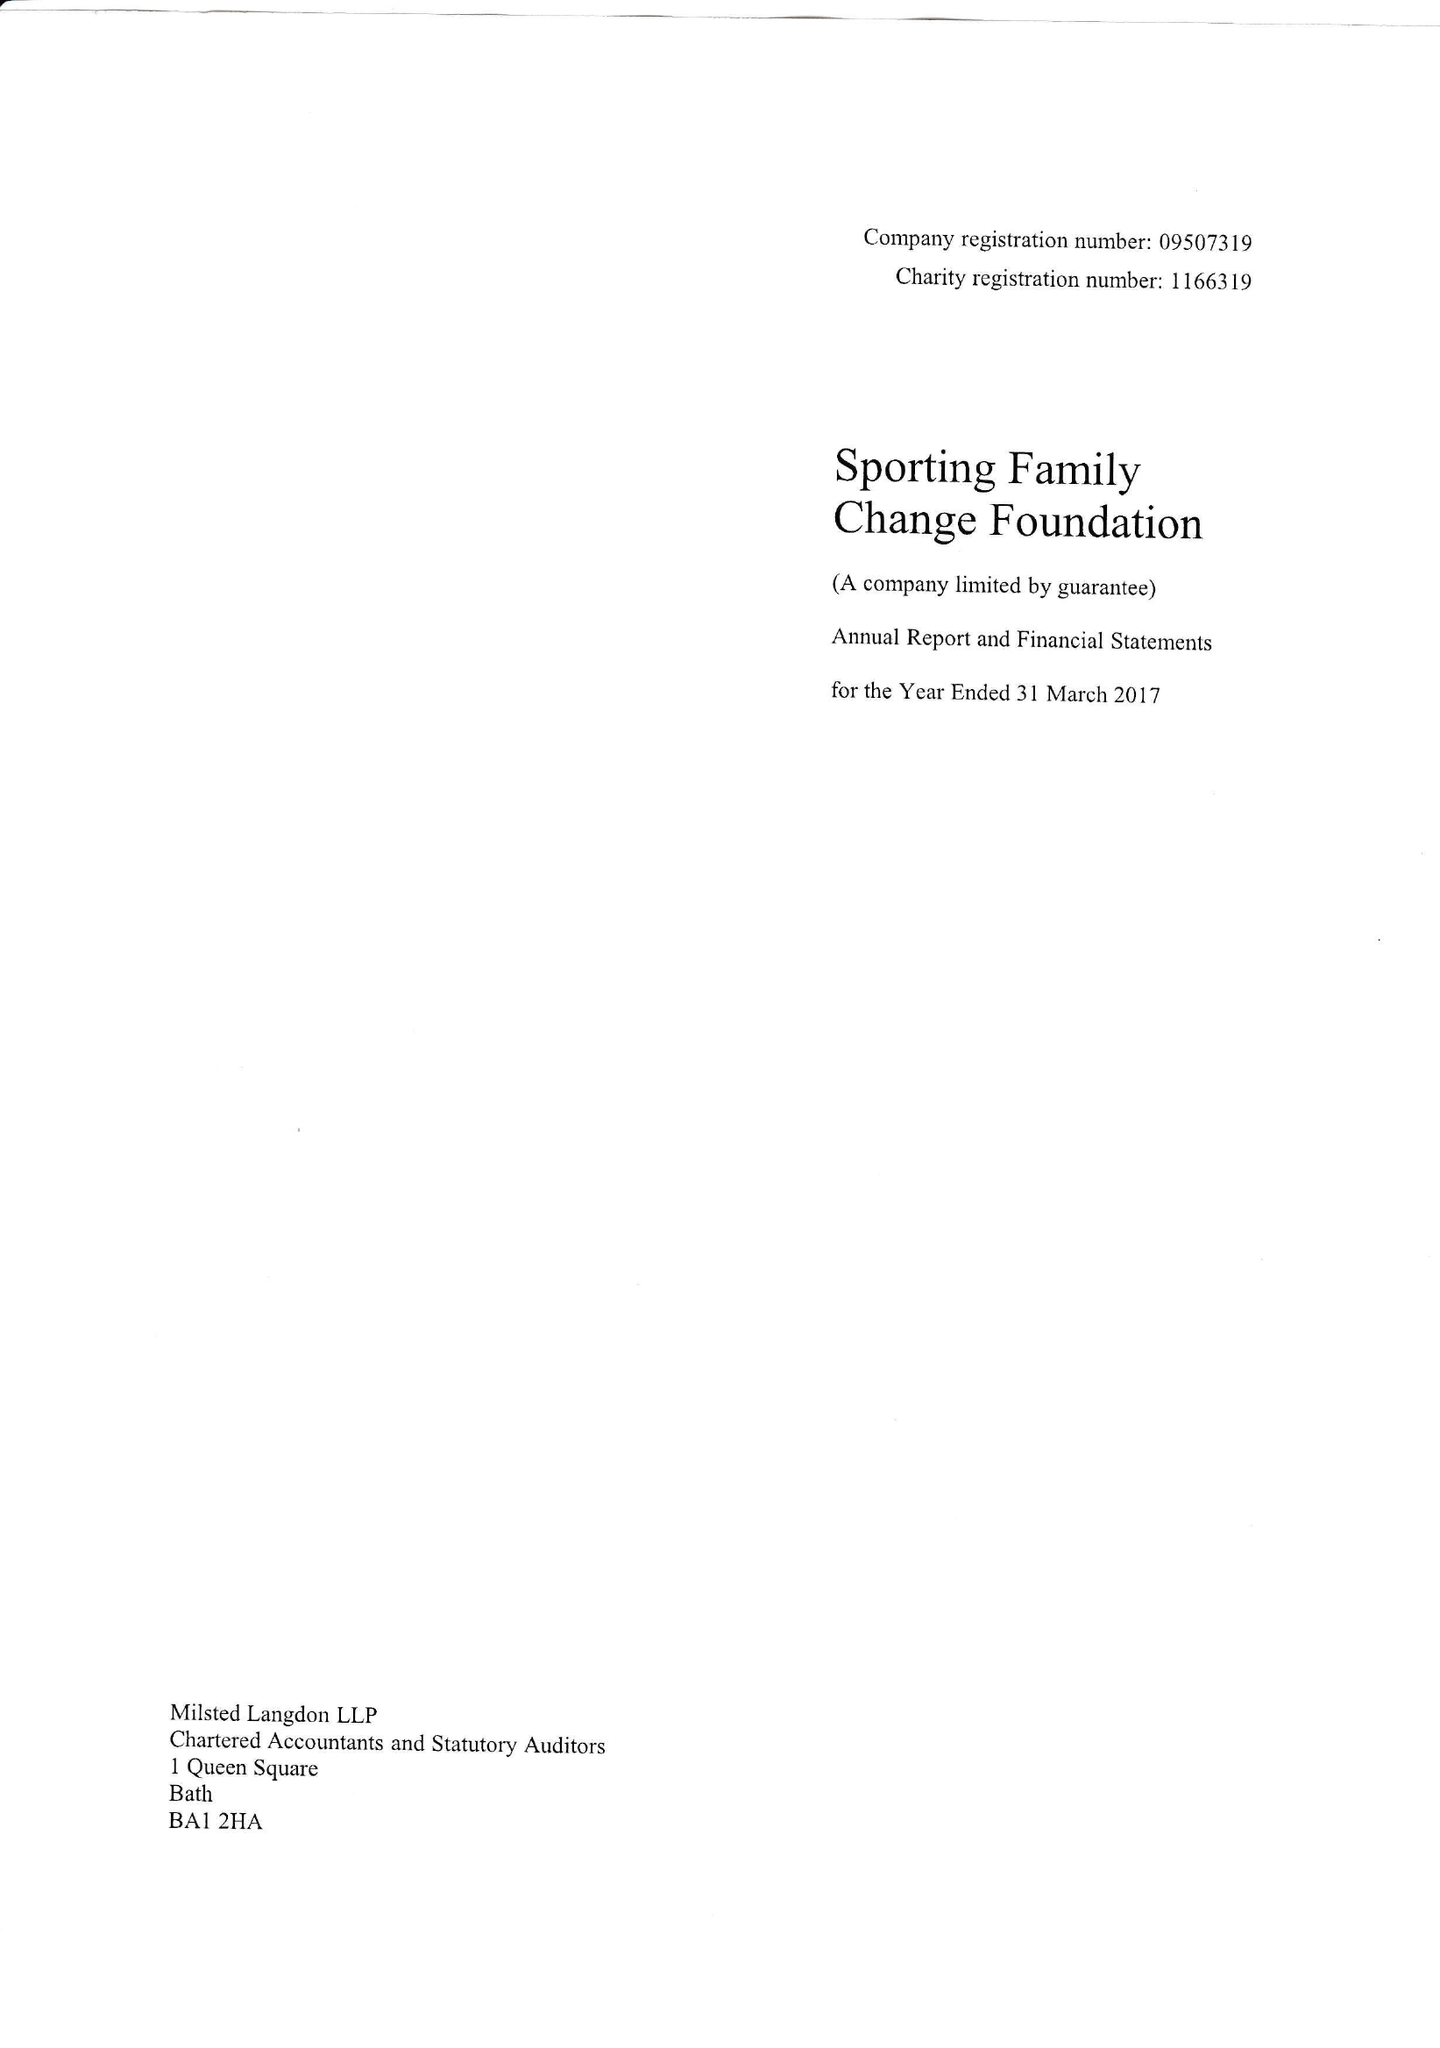What is the value for the spending_annually_in_british_pounds?
Answer the question using a single word or phrase. 144183.00 